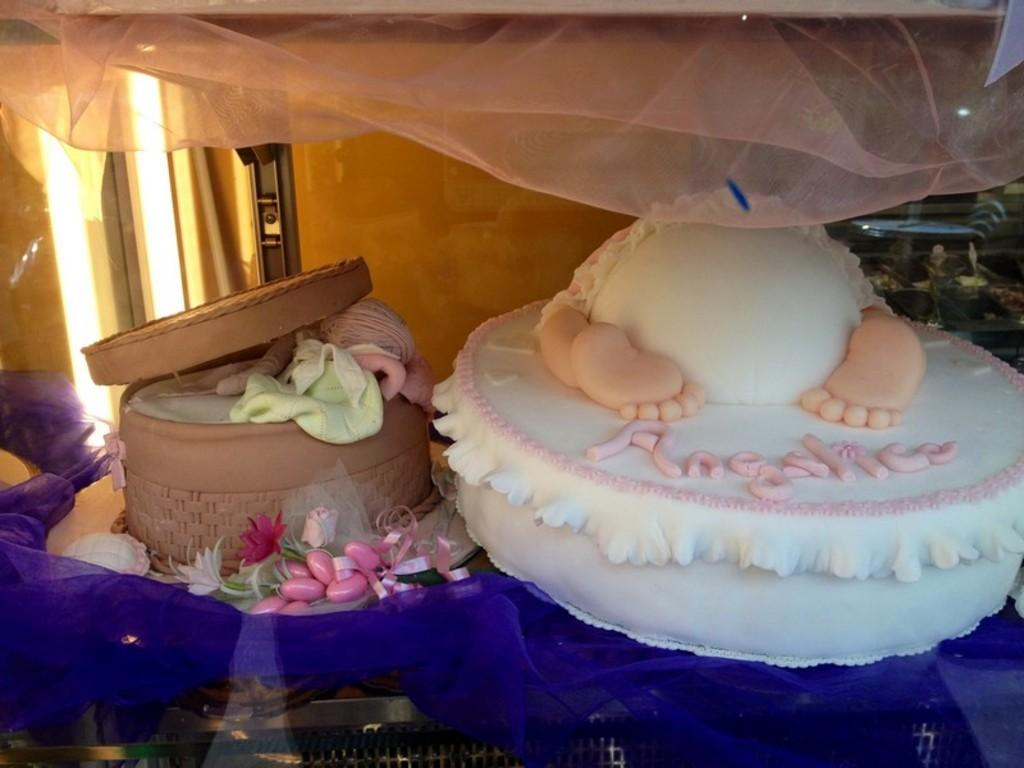What type of food can be seen in the image? There are cakes in the image. What is the cakes resting on? The cakes are on an object. What can be seen behind the cakes? There is a wall visible behind the cakes. Can you describe any other items visible in the image? There are other unspecified things visible in the image. What time of day is it in the image, based on the presence of babies in the bath? There are no babies or bath present in the image, so we cannot determine the time of day based on that information. 